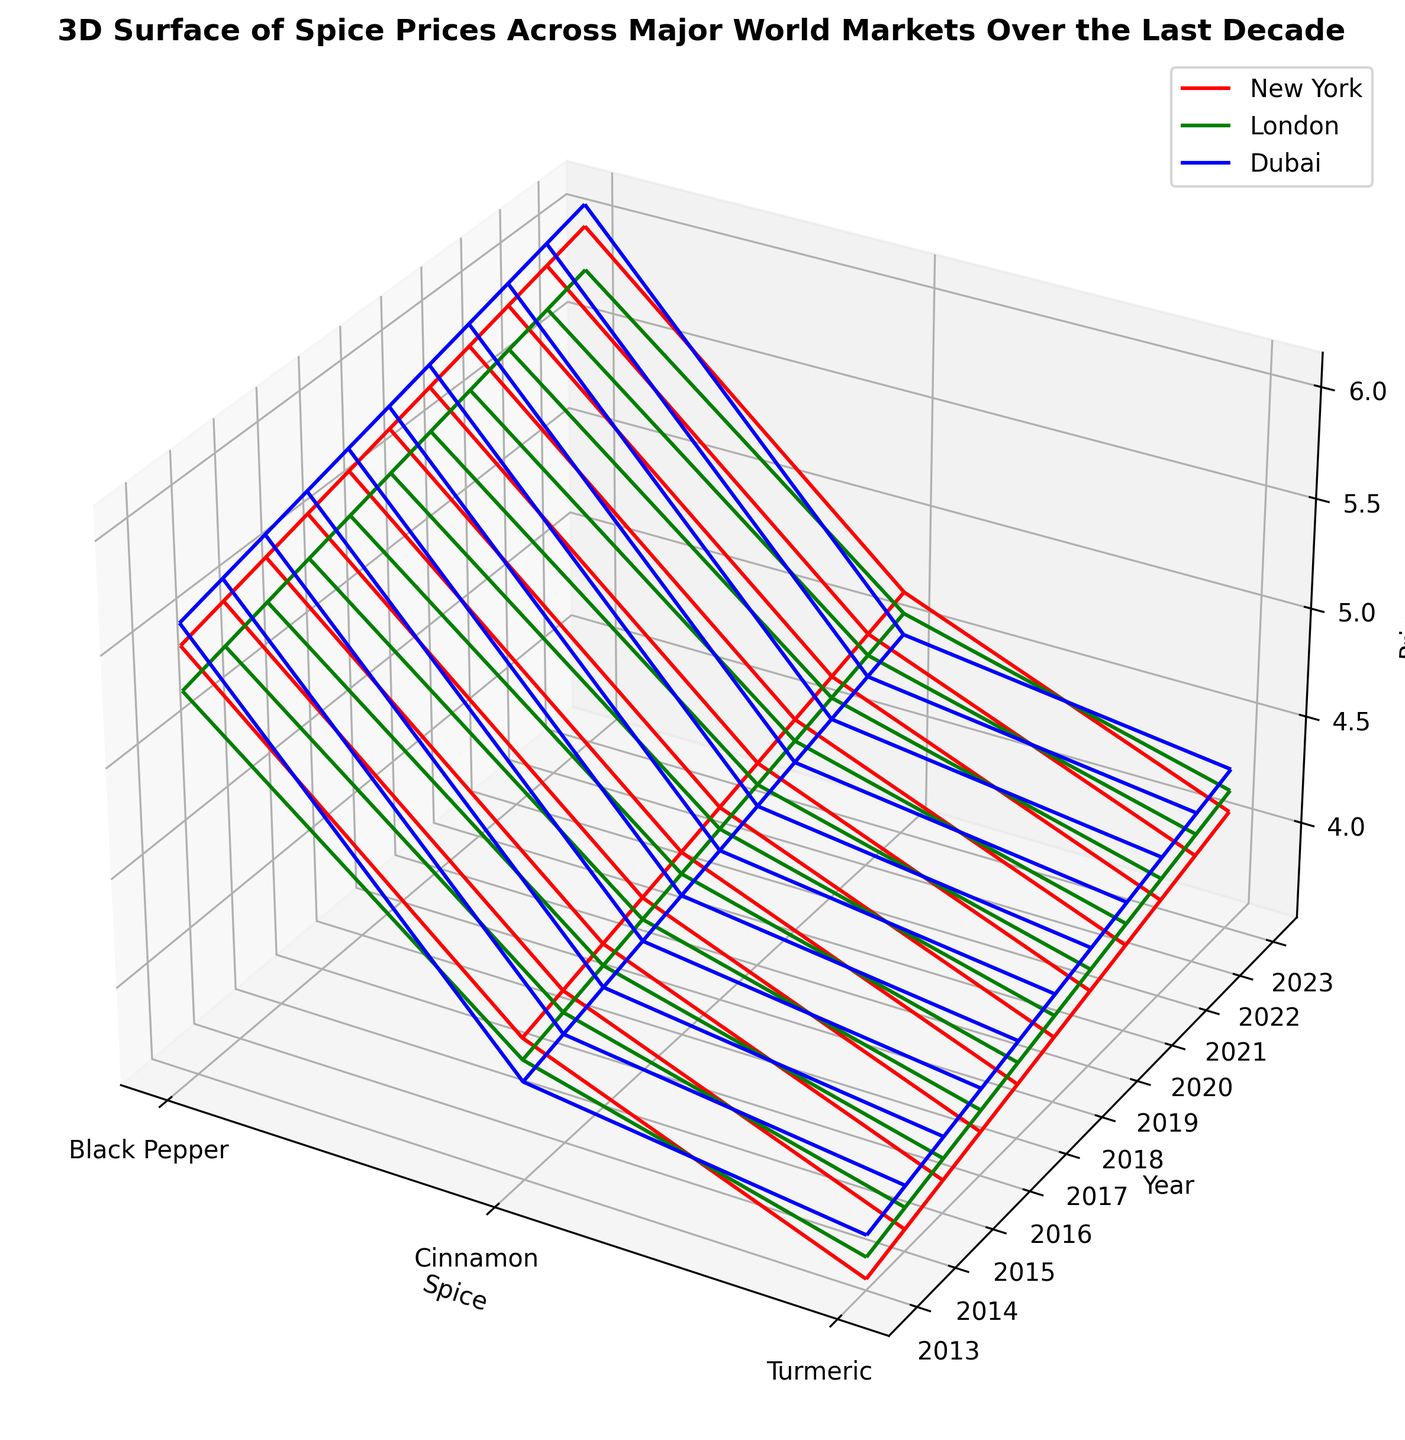What's the general trend in the price of Black Pepper in Dubai over the last decade? The red wireframe representing Dubai in the figure shows that the price of Black Pepper consistently rises from the start of the decade to the end.
Answer: Increasing Which spice had the most stable price in London? By examining the green wireframe representing London, Cinnamon shows the least fluctuation in its prices over the years compared to Black Pepper and Turmeric.
Answer: Cinnamon What is the difference between the maximum and minimum price of Turmeric in New York? The blue wireframe representing New York shows the price range of Turmeric. The maximum price is around 4.10 in 2023, and the minimum price is around 3.60 in 2013. Therefore, the difference is 4.10 - 3.60 = 0.50.
Answer: 0.50 Compare the price trend of Cinnamon in New York and London. Which one experienced a more significant increase? Looking at the wireframes for New York (red) and London (green) for Cinnamon, New York starts at 4.20 in 2013 and ends at 4.70 in 2023 (increase of 0.50), whereas London starts at 4.10 and ends at 4.60 (increase of 0.50). Both experienced the same increase of 0.50.
Answer: Both experienced the same increase Which market has the highest price for Turmeric in 2022? By observing the wireframes, Dubai (blue) has the highest point for Turmeric in 2022 with a price of about 4.25 compared to New York and London.
Answer: Dubai How does the price of Black Pepper in London in 2023 compare to its price in New York in 2020? In the figure, the price of Black Pepper in London in 2023 is around 5.80, while in New York in 2020, it is around 5.85. Thus, the price in London in 2023 is slightly lower.
Answer: Lower What's the average price of Cinnamon across all markets in 2020? New York: 4.55, London: 4.45, Dubai: 4.35. Adding these = 4.55 + 4.45 + 4.35 = 13.35, dividing by 3 markets = 13.35 / 3 ≈ 4.45.
Answer: 4.45 Which spice in Dubai showed the highest price increase from 2013 to 2023? By examining the blue wireframe for Dubai, Black Pepper increased from around 5.60 in 2013 to around 6.10 in 2023, which is the highest increase among the spices.
Answer: Black Pepper How do the prices of Turmeric in New York and Dubai in 2023 compare? The figure shows that in 2023, the price of Turmeric in New York is around 4.10, while in Dubai, it is around 4.30, indicating that Dubai's price is higher.
Answer: Dubai's price is higher 